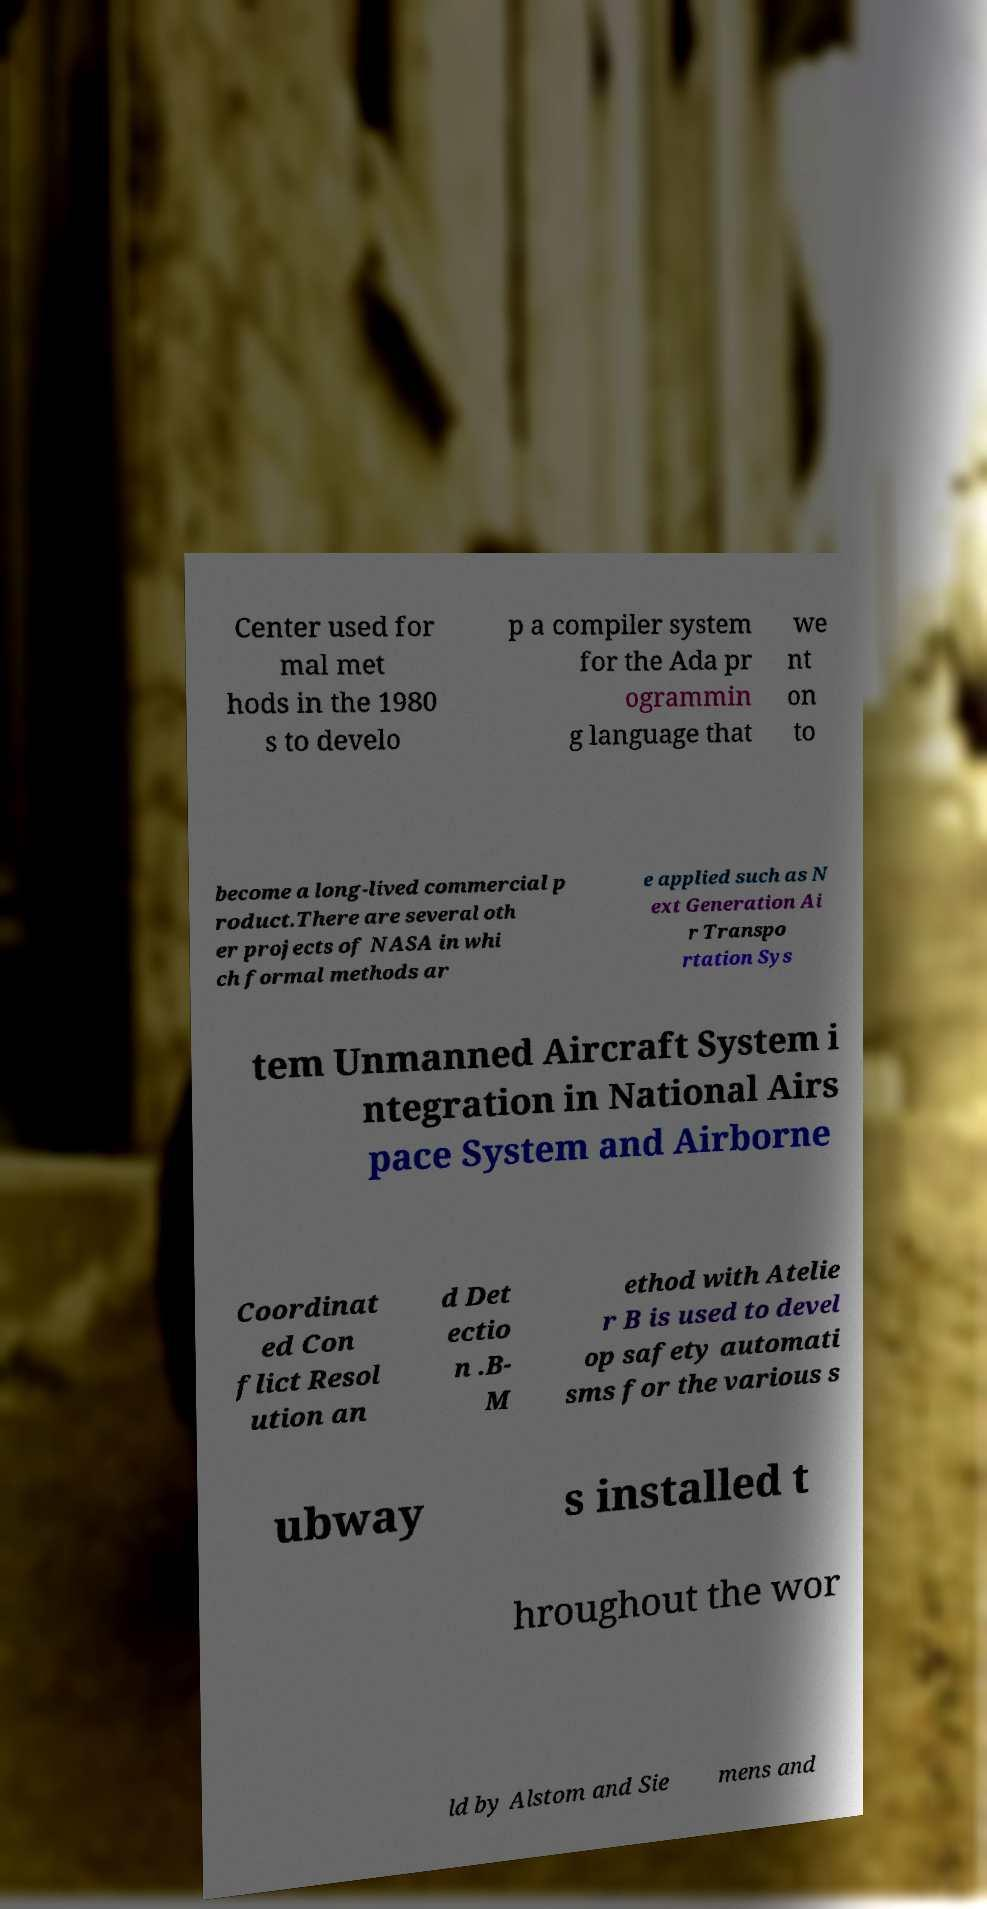For documentation purposes, I need the text within this image transcribed. Could you provide that? Center used for mal met hods in the 1980 s to develo p a compiler system for the Ada pr ogrammin g language that we nt on to become a long-lived commercial p roduct.There are several oth er projects of NASA in whi ch formal methods ar e applied such as N ext Generation Ai r Transpo rtation Sys tem Unmanned Aircraft System i ntegration in National Airs pace System and Airborne Coordinat ed Con flict Resol ution an d Det ectio n .B- M ethod with Atelie r B is used to devel op safety automati sms for the various s ubway s installed t hroughout the wor ld by Alstom and Sie mens and 